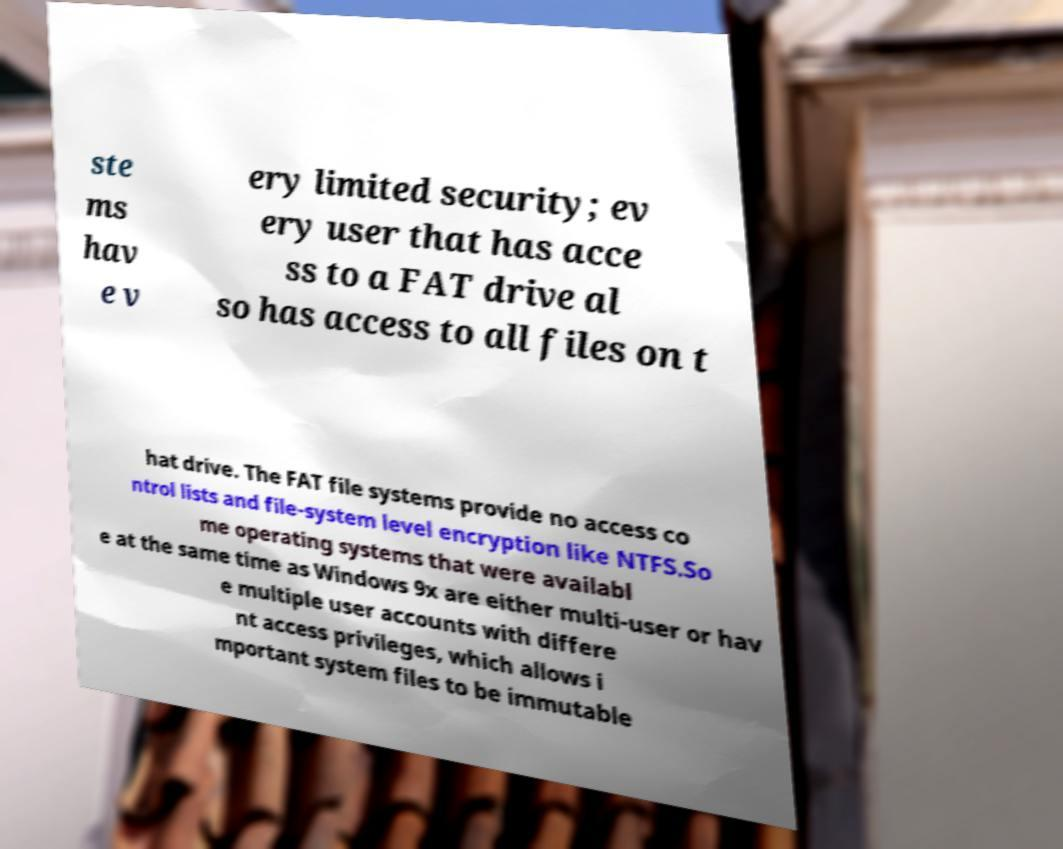What messages or text are displayed in this image? I need them in a readable, typed format. ste ms hav e v ery limited security; ev ery user that has acce ss to a FAT drive al so has access to all files on t hat drive. The FAT file systems provide no access co ntrol lists and file-system level encryption like NTFS.So me operating systems that were availabl e at the same time as Windows 9x are either multi-user or hav e multiple user accounts with differe nt access privileges, which allows i mportant system files to be immutable 